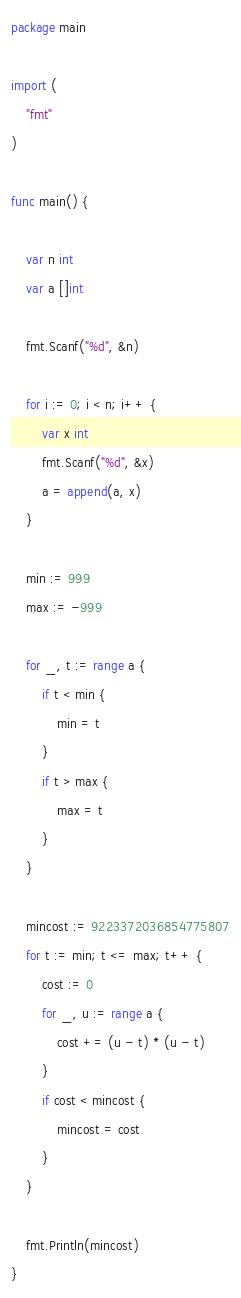Convert code to text. <code><loc_0><loc_0><loc_500><loc_500><_Go_>package main

import (
	"fmt"
)

func main() {

	var n int
	var a []int

	fmt.Scanf("%d", &n)

	for i := 0; i < n; i++ {
		var x int
		fmt.Scanf("%d", &x)
		a = append(a, x)
	}

	min := 999
	max := -999

	for _, t := range a {
		if t < min {
			min = t
		}
		if t > max {
			max = t
		}
	}

	mincost := 9223372036854775807
	for t := min; t <= max; t++ {
		cost := 0
		for _, u := range a {
			cost += (u - t) * (u - t)
		}
		if cost < mincost {
			mincost = cost
		}
	}

	fmt.Println(mincost)
}
</code> 